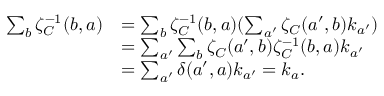Convert formula to latex. <formula><loc_0><loc_0><loc_500><loc_500>\begin{array} { r l } { \sum _ { b } \zeta _ { C } ^ { - 1 } ( b , a ) } & { = \sum _ { b } \zeta _ { C } ^ { - 1 } ( b , a ) ( \sum _ { a ^ { \prime } } \zeta _ { C } ( a ^ { \prime } , b ) k _ { a ^ { \prime } } ) } \\ & { = \sum _ { a ^ { \prime } } \sum _ { b } \zeta _ { C } ( a ^ { \prime } , b ) \zeta _ { C } ^ { - 1 } ( b , a ) k _ { a ^ { \prime } } } \\ & { = \sum _ { a ^ { \prime } } \delta ( a ^ { \prime } , a ) k _ { a ^ { \prime } } = k _ { a } . } \end{array}</formula> 